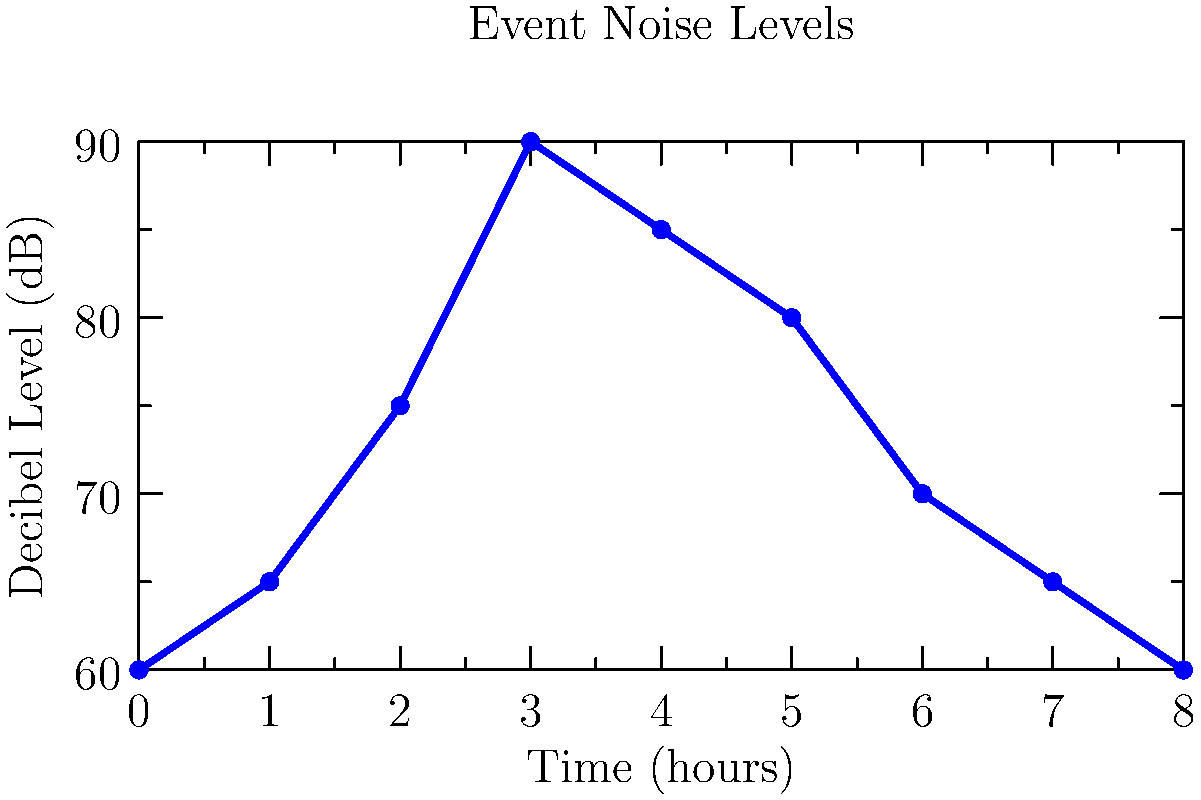During an 8-hour event, noise levels were recorded hourly as shown in the graph. What is the duration of the peak noise period where the decibel level exceeded 80 dB, and at which hour did this peak occur? To answer this question, we need to analyze the graph carefully:

1. Identify the threshold: We're looking for periods where the noise level exceeded 80 dB.

2. Scan the graph: We can see that the noise level rises above 80 dB between the 2nd and 5th hour.

3. Determine the peak:
   - The highest point on the graph is at the 3rd hour, reaching 90 dB.

4. Calculate the duration:
   - The noise level exceeds 80 dB from hour 3 to hour 4.
   - This represents a 1-hour duration.

5. Identify the start time of the peak:
   - The peak begins at the 3rd hour.

Therefore, the peak noise period lasted for 1 hour and occurred at the 3rd hour of the event.
Answer: 1 hour, 3rd hour 